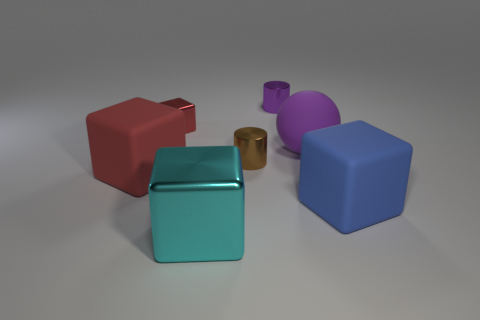Do the rubber object that is right of the big purple rubber object and the small purple thing have the same shape?
Offer a terse response. No. What number of purple things are behind the cube on the right side of the tiny metal cylinder behind the brown metallic cylinder?
Keep it short and to the point. 2. Is there any other thing that is the same shape as the purple rubber thing?
Provide a succinct answer. No. What number of things are small yellow cylinders or rubber balls?
Your answer should be compact. 1. There is a purple shiny object; is its shape the same as the tiny shiny object that is in front of the purple matte sphere?
Give a very brief answer. Yes. There is a matte object behind the tiny brown metallic cylinder; what is its shape?
Your answer should be compact. Sphere. Is the red metal thing the same shape as the large red object?
Your response must be concise. Yes. What is the size of the purple object that is the same shape as the brown object?
Your response must be concise. Small. There is a metallic cylinder in front of the purple shiny thing; does it have the same size as the small block?
Provide a short and direct response. Yes. How big is the rubber thing that is behind the blue thing and right of the tiny red block?
Provide a succinct answer. Large. 